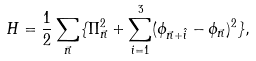<formula> <loc_0><loc_0><loc_500><loc_500>H = \frac { 1 } { 2 } \sum _ { \vec { n } } \{ \Pi _ { \vec { n } } ^ { 2 } + \sum _ { i = 1 } ^ { 3 } ( \phi _ { \vec { n } + \hat { i } } - \phi _ { \vec { n } } ) ^ { 2 } \} ,</formula> 